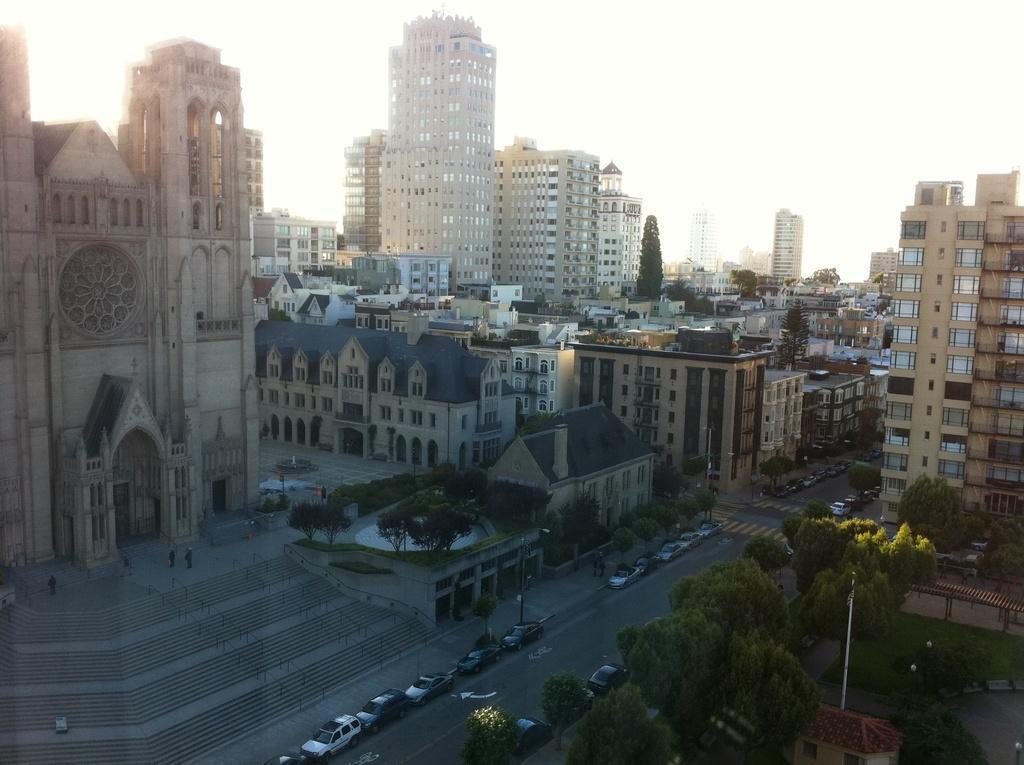In one or two sentences, can you explain what this image depicts? In this image I can see a road in the centre and on it I can see number of vehicles. On the both side of road I can see number of buildings, number of trees, few poles and on the right side of this image I can see few people are standing. I can also see stairs and railings on the bottom right side of this image. 